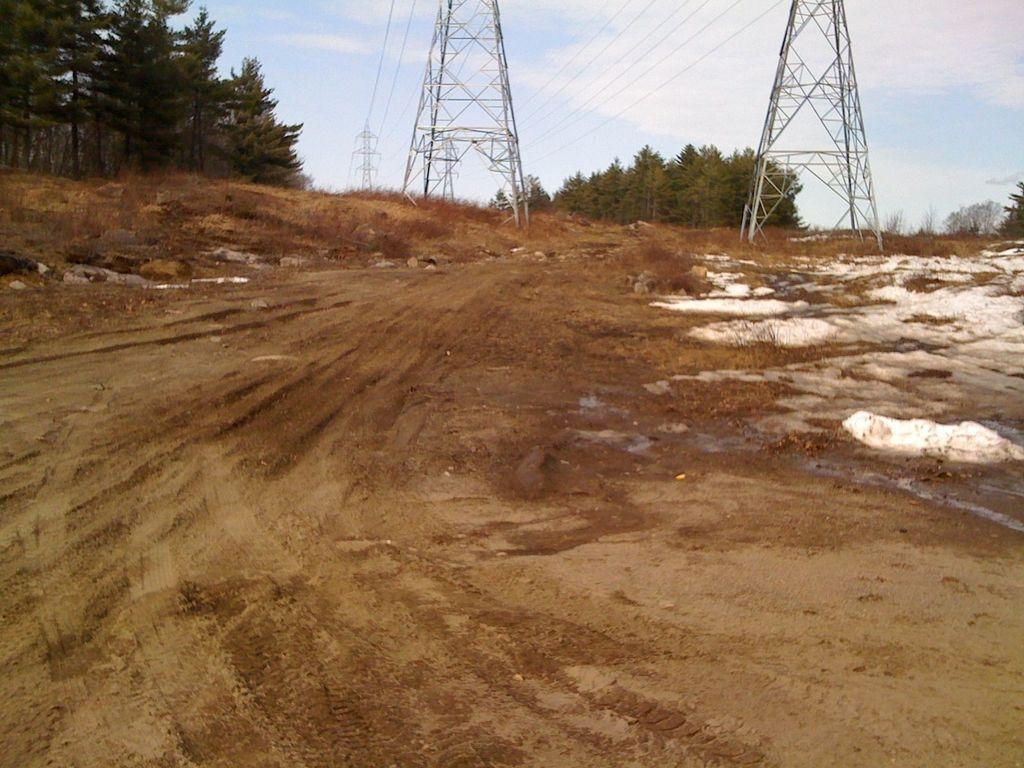What can be seen in the top left of the image? There are trees in the top left of the image. What structures are visible in the background of the image? There are towers in the background of the image. What else can be seen in the background of the image? There are trees in the background of the image. What is present on the ground in the image? There are plants on the ground in the image. What can be observed in the sky in the image? There are patches of clouds in the sky in the image. What type of pet can be seen playing with a machine in the image? There is no pet or machine present in the image. How does the digestion process appear in the image? There is no digestion process depicted in the image. 